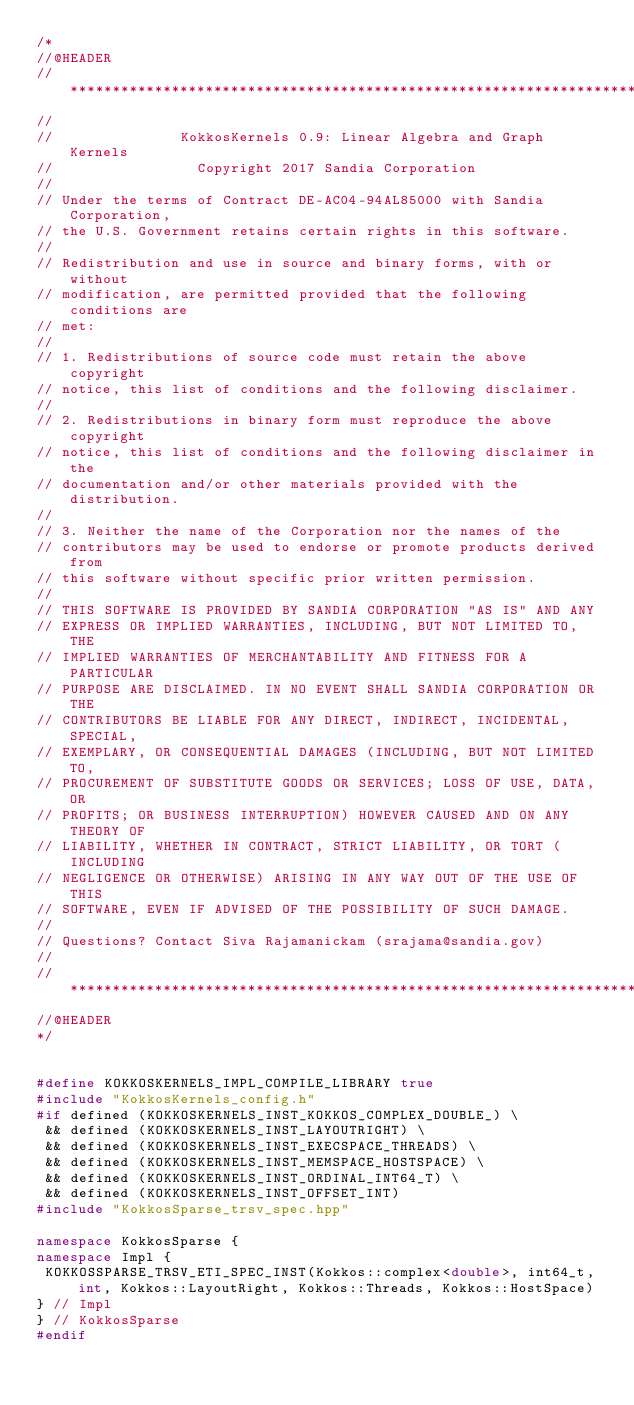Convert code to text. <code><loc_0><loc_0><loc_500><loc_500><_C++_>/*
//@HEADER
// ************************************************************************
//
//               KokkosKernels 0.9: Linear Algebra and Graph Kernels
//                 Copyright 2017 Sandia Corporation
//
// Under the terms of Contract DE-AC04-94AL85000 with Sandia Corporation,
// the U.S. Government retains certain rights in this software.
//
// Redistribution and use in source and binary forms, with or without
// modification, are permitted provided that the following conditions are
// met:
//
// 1. Redistributions of source code must retain the above copyright
// notice, this list of conditions and the following disclaimer.
//
// 2. Redistributions in binary form must reproduce the above copyright
// notice, this list of conditions and the following disclaimer in the
// documentation and/or other materials provided with the distribution.
//
// 3. Neither the name of the Corporation nor the names of the
// contributors may be used to endorse or promote products derived from
// this software without specific prior written permission.
//
// THIS SOFTWARE IS PROVIDED BY SANDIA CORPORATION "AS IS" AND ANY
// EXPRESS OR IMPLIED WARRANTIES, INCLUDING, BUT NOT LIMITED TO, THE
// IMPLIED WARRANTIES OF MERCHANTABILITY AND FITNESS FOR A PARTICULAR
// PURPOSE ARE DISCLAIMED. IN NO EVENT SHALL SANDIA CORPORATION OR THE
// CONTRIBUTORS BE LIABLE FOR ANY DIRECT, INDIRECT, INCIDENTAL, SPECIAL,
// EXEMPLARY, OR CONSEQUENTIAL DAMAGES (INCLUDING, BUT NOT LIMITED TO,
// PROCUREMENT OF SUBSTITUTE GOODS OR SERVICES; LOSS OF USE, DATA, OR
// PROFITS; OR BUSINESS INTERRUPTION) HOWEVER CAUSED AND ON ANY THEORY OF
// LIABILITY, WHETHER IN CONTRACT, STRICT LIABILITY, OR TORT (INCLUDING
// NEGLIGENCE OR OTHERWISE) ARISING IN ANY WAY OUT OF THE USE OF THIS
// SOFTWARE, EVEN IF ADVISED OF THE POSSIBILITY OF SUCH DAMAGE.
//
// Questions? Contact Siva Rajamanickam (srajama@sandia.gov)
//
// ************************************************************************
//@HEADER
*/


#define KOKKOSKERNELS_IMPL_COMPILE_LIBRARY true
#include "KokkosKernels_config.h"
#if defined (KOKKOSKERNELS_INST_KOKKOS_COMPLEX_DOUBLE_) \
 && defined (KOKKOSKERNELS_INST_LAYOUTRIGHT) \
 && defined (KOKKOSKERNELS_INST_EXECSPACE_THREADS) \
 && defined (KOKKOSKERNELS_INST_MEMSPACE_HOSTSPACE) \
 && defined (KOKKOSKERNELS_INST_ORDINAL_INT64_T) \
 && defined (KOKKOSKERNELS_INST_OFFSET_INT) 
#include "KokkosSparse_trsv_spec.hpp"

namespace KokkosSparse {
namespace Impl {
 KOKKOSSPARSE_TRSV_ETI_SPEC_INST(Kokkos::complex<double>, int64_t, int, Kokkos::LayoutRight, Kokkos::Threads, Kokkos::HostSpace)
} // Impl
} // KokkosSparse
#endif
</code> 